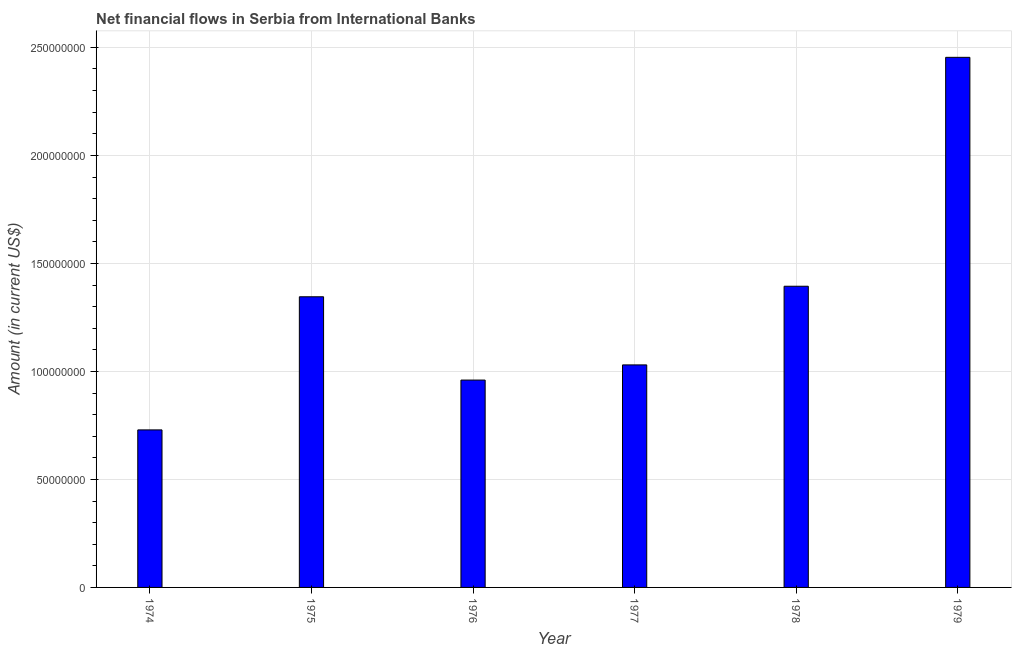What is the title of the graph?
Your answer should be compact. Net financial flows in Serbia from International Banks. What is the net financial flows from ibrd in 1976?
Offer a terse response. 9.60e+07. Across all years, what is the maximum net financial flows from ibrd?
Offer a terse response. 2.45e+08. Across all years, what is the minimum net financial flows from ibrd?
Give a very brief answer. 7.29e+07. In which year was the net financial flows from ibrd maximum?
Ensure brevity in your answer.  1979. In which year was the net financial flows from ibrd minimum?
Provide a succinct answer. 1974. What is the sum of the net financial flows from ibrd?
Offer a terse response. 7.91e+08. What is the difference between the net financial flows from ibrd in 1975 and 1977?
Offer a terse response. 3.15e+07. What is the average net financial flows from ibrd per year?
Ensure brevity in your answer.  1.32e+08. What is the median net financial flows from ibrd?
Give a very brief answer. 1.19e+08. In how many years, is the net financial flows from ibrd greater than 180000000 US$?
Make the answer very short. 1. What is the ratio of the net financial flows from ibrd in 1978 to that in 1979?
Your answer should be very brief. 0.57. Is the difference between the net financial flows from ibrd in 1975 and 1977 greater than the difference between any two years?
Your answer should be compact. No. What is the difference between the highest and the second highest net financial flows from ibrd?
Provide a short and direct response. 1.06e+08. Is the sum of the net financial flows from ibrd in 1976 and 1979 greater than the maximum net financial flows from ibrd across all years?
Your response must be concise. Yes. What is the difference between the highest and the lowest net financial flows from ibrd?
Your answer should be compact. 1.72e+08. How many bars are there?
Provide a succinct answer. 6. Are all the bars in the graph horizontal?
Offer a terse response. No. What is the difference between two consecutive major ticks on the Y-axis?
Ensure brevity in your answer.  5.00e+07. Are the values on the major ticks of Y-axis written in scientific E-notation?
Offer a terse response. No. What is the Amount (in current US$) of 1974?
Provide a succinct answer. 7.29e+07. What is the Amount (in current US$) in 1975?
Your answer should be very brief. 1.35e+08. What is the Amount (in current US$) in 1976?
Ensure brevity in your answer.  9.60e+07. What is the Amount (in current US$) of 1977?
Your answer should be compact. 1.03e+08. What is the Amount (in current US$) of 1978?
Your response must be concise. 1.39e+08. What is the Amount (in current US$) in 1979?
Provide a succinct answer. 2.45e+08. What is the difference between the Amount (in current US$) in 1974 and 1975?
Your answer should be compact. -6.16e+07. What is the difference between the Amount (in current US$) in 1974 and 1976?
Provide a succinct answer. -2.31e+07. What is the difference between the Amount (in current US$) in 1974 and 1977?
Ensure brevity in your answer.  -3.01e+07. What is the difference between the Amount (in current US$) in 1974 and 1978?
Provide a short and direct response. -6.65e+07. What is the difference between the Amount (in current US$) in 1974 and 1979?
Provide a short and direct response. -1.72e+08. What is the difference between the Amount (in current US$) in 1975 and 1976?
Your response must be concise. 3.86e+07. What is the difference between the Amount (in current US$) in 1975 and 1977?
Offer a terse response. 3.15e+07. What is the difference between the Amount (in current US$) in 1975 and 1978?
Your answer should be very brief. -4.88e+06. What is the difference between the Amount (in current US$) in 1975 and 1979?
Your response must be concise. -1.11e+08. What is the difference between the Amount (in current US$) in 1976 and 1977?
Give a very brief answer. -7.02e+06. What is the difference between the Amount (in current US$) in 1976 and 1978?
Offer a terse response. -4.34e+07. What is the difference between the Amount (in current US$) in 1976 and 1979?
Offer a very short reply. -1.49e+08. What is the difference between the Amount (in current US$) in 1977 and 1978?
Provide a short and direct response. -3.64e+07. What is the difference between the Amount (in current US$) in 1977 and 1979?
Offer a terse response. -1.42e+08. What is the difference between the Amount (in current US$) in 1978 and 1979?
Provide a short and direct response. -1.06e+08. What is the ratio of the Amount (in current US$) in 1974 to that in 1975?
Give a very brief answer. 0.54. What is the ratio of the Amount (in current US$) in 1974 to that in 1976?
Your answer should be very brief. 0.76. What is the ratio of the Amount (in current US$) in 1974 to that in 1977?
Your answer should be very brief. 0.71. What is the ratio of the Amount (in current US$) in 1974 to that in 1978?
Provide a succinct answer. 0.52. What is the ratio of the Amount (in current US$) in 1974 to that in 1979?
Your answer should be compact. 0.3. What is the ratio of the Amount (in current US$) in 1975 to that in 1976?
Keep it short and to the point. 1.4. What is the ratio of the Amount (in current US$) in 1975 to that in 1977?
Ensure brevity in your answer.  1.31. What is the ratio of the Amount (in current US$) in 1975 to that in 1979?
Ensure brevity in your answer.  0.55. What is the ratio of the Amount (in current US$) in 1976 to that in 1977?
Provide a succinct answer. 0.93. What is the ratio of the Amount (in current US$) in 1976 to that in 1978?
Keep it short and to the point. 0.69. What is the ratio of the Amount (in current US$) in 1976 to that in 1979?
Keep it short and to the point. 0.39. What is the ratio of the Amount (in current US$) in 1977 to that in 1978?
Provide a short and direct response. 0.74. What is the ratio of the Amount (in current US$) in 1977 to that in 1979?
Offer a terse response. 0.42. What is the ratio of the Amount (in current US$) in 1978 to that in 1979?
Give a very brief answer. 0.57. 